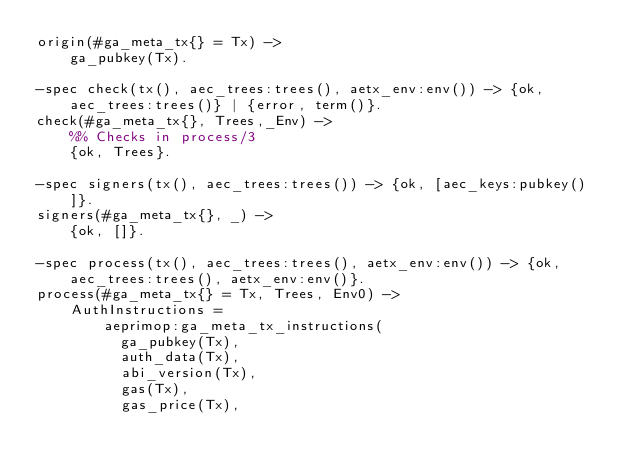Convert code to text. <code><loc_0><loc_0><loc_500><loc_500><_Erlang_>origin(#ga_meta_tx{} = Tx) ->
    ga_pubkey(Tx).

-spec check(tx(), aec_trees:trees(), aetx_env:env()) -> {ok, aec_trees:trees()} | {error, term()}.
check(#ga_meta_tx{}, Trees,_Env) ->
    %% Checks in process/3
    {ok, Trees}.

-spec signers(tx(), aec_trees:trees()) -> {ok, [aec_keys:pubkey()]}.
signers(#ga_meta_tx{}, _) ->
    {ok, []}.

-spec process(tx(), aec_trees:trees(), aetx_env:env()) -> {ok, aec_trees:trees(), aetx_env:env()}.
process(#ga_meta_tx{} = Tx, Trees, Env0) ->
    AuthInstructions =
        aeprimop:ga_meta_tx_instructions(
          ga_pubkey(Tx),
          auth_data(Tx),
          abi_version(Tx),
          gas(Tx),
          gas_price(Tx),</code> 